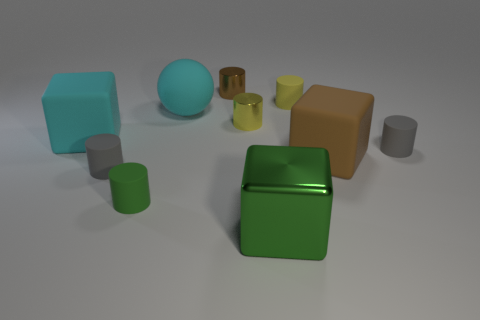Subtract all cyan blocks. How many gray cylinders are left? 2 Subtract all large matte blocks. How many blocks are left? 1 Subtract all brown cylinders. How many cylinders are left? 5 Subtract all spheres. How many objects are left? 9 Subtract 1 blocks. How many blocks are left? 2 Subtract all cyan cylinders. Subtract all purple balls. How many cylinders are left? 6 Subtract all gray cylinders. Subtract all rubber balls. How many objects are left? 7 Add 6 metal cylinders. How many metal cylinders are left? 8 Add 6 tiny green objects. How many tiny green objects exist? 7 Subtract 0 red blocks. How many objects are left? 10 